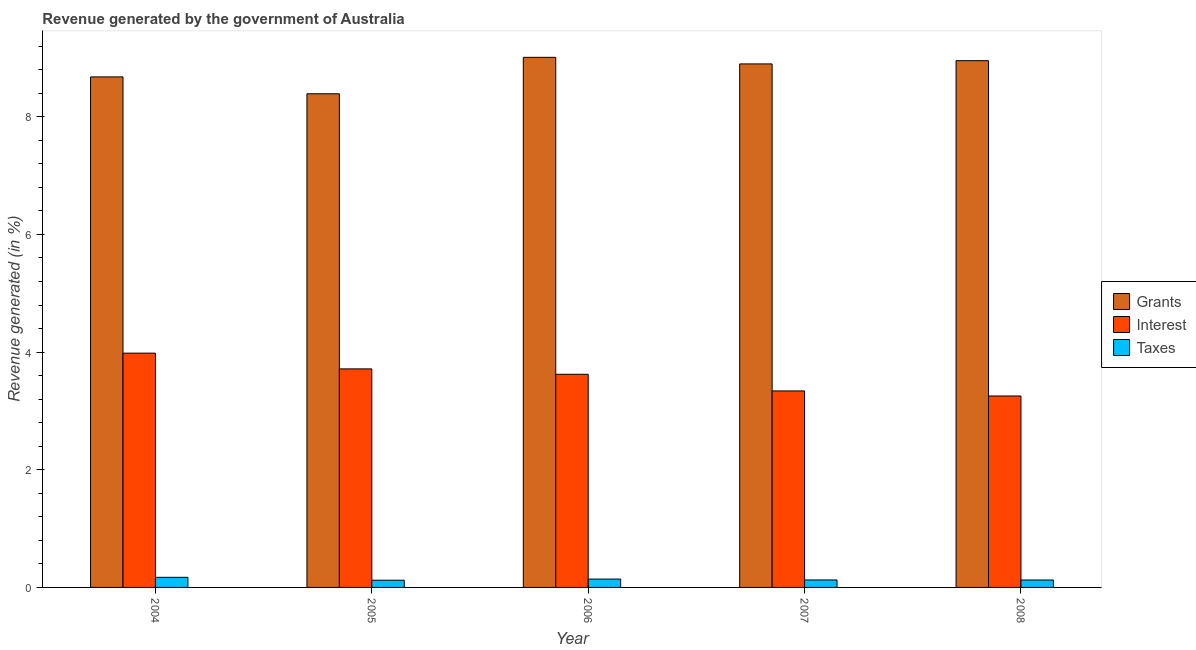How many groups of bars are there?
Ensure brevity in your answer.  5. Are the number of bars per tick equal to the number of legend labels?
Ensure brevity in your answer.  Yes. Are the number of bars on each tick of the X-axis equal?
Make the answer very short. Yes. How many bars are there on the 1st tick from the left?
Keep it short and to the point. 3. What is the percentage of revenue generated by grants in 2006?
Your answer should be compact. 9.01. Across all years, what is the maximum percentage of revenue generated by grants?
Make the answer very short. 9.01. Across all years, what is the minimum percentage of revenue generated by taxes?
Make the answer very short. 0.12. In which year was the percentage of revenue generated by taxes maximum?
Ensure brevity in your answer.  2004. In which year was the percentage of revenue generated by interest minimum?
Offer a very short reply. 2008. What is the total percentage of revenue generated by grants in the graph?
Give a very brief answer. 43.93. What is the difference between the percentage of revenue generated by grants in 2007 and that in 2008?
Ensure brevity in your answer.  -0.06. What is the difference between the percentage of revenue generated by grants in 2007 and the percentage of revenue generated by taxes in 2004?
Your answer should be compact. 0.22. What is the average percentage of revenue generated by taxes per year?
Provide a succinct answer. 0.14. In the year 2008, what is the difference between the percentage of revenue generated by grants and percentage of revenue generated by taxes?
Offer a terse response. 0. What is the ratio of the percentage of revenue generated by grants in 2004 to that in 2008?
Provide a short and direct response. 0.97. Is the percentage of revenue generated by taxes in 2004 less than that in 2008?
Give a very brief answer. No. What is the difference between the highest and the second highest percentage of revenue generated by taxes?
Offer a very short reply. 0.03. What is the difference between the highest and the lowest percentage of revenue generated by taxes?
Your answer should be very brief. 0.05. Is the sum of the percentage of revenue generated by grants in 2005 and 2008 greater than the maximum percentage of revenue generated by taxes across all years?
Provide a short and direct response. Yes. What does the 1st bar from the left in 2004 represents?
Give a very brief answer. Grants. What does the 1st bar from the right in 2004 represents?
Your response must be concise. Taxes. Is it the case that in every year, the sum of the percentage of revenue generated by grants and percentage of revenue generated by interest is greater than the percentage of revenue generated by taxes?
Provide a short and direct response. Yes. How many bars are there?
Offer a very short reply. 15. Are all the bars in the graph horizontal?
Offer a terse response. No. What is the difference between two consecutive major ticks on the Y-axis?
Make the answer very short. 2. Does the graph contain grids?
Ensure brevity in your answer.  No. How are the legend labels stacked?
Your response must be concise. Vertical. What is the title of the graph?
Keep it short and to the point. Revenue generated by the government of Australia. Does "Injury" appear as one of the legend labels in the graph?
Keep it short and to the point. No. What is the label or title of the Y-axis?
Your answer should be compact. Revenue generated (in %). What is the Revenue generated (in %) in Grants in 2004?
Keep it short and to the point. 8.68. What is the Revenue generated (in %) of Interest in 2004?
Your answer should be very brief. 3.98. What is the Revenue generated (in %) of Taxes in 2004?
Provide a short and direct response. 0.17. What is the Revenue generated (in %) of Grants in 2005?
Make the answer very short. 8.39. What is the Revenue generated (in %) in Interest in 2005?
Provide a short and direct response. 3.71. What is the Revenue generated (in %) of Taxes in 2005?
Offer a terse response. 0.12. What is the Revenue generated (in %) in Grants in 2006?
Keep it short and to the point. 9.01. What is the Revenue generated (in %) in Interest in 2006?
Your answer should be compact. 3.62. What is the Revenue generated (in %) of Taxes in 2006?
Give a very brief answer. 0.14. What is the Revenue generated (in %) in Grants in 2007?
Make the answer very short. 8.9. What is the Revenue generated (in %) in Interest in 2007?
Provide a succinct answer. 3.34. What is the Revenue generated (in %) of Taxes in 2007?
Your answer should be very brief. 0.13. What is the Revenue generated (in %) of Grants in 2008?
Make the answer very short. 8.95. What is the Revenue generated (in %) of Interest in 2008?
Make the answer very short. 3.25. What is the Revenue generated (in %) of Taxes in 2008?
Make the answer very short. 0.13. Across all years, what is the maximum Revenue generated (in %) in Grants?
Keep it short and to the point. 9.01. Across all years, what is the maximum Revenue generated (in %) of Interest?
Your answer should be compact. 3.98. Across all years, what is the maximum Revenue generated (in %) of Taxes?
Ensure brevity in your answer.  0.17. Across all years, what is the minimum Revenue generated (in %) in Grants?
Ensure brevity in your answer.  8.39. Across all years, what is the minimum Revenue generated (in %) in Interest?
Provide a short and direct response. 3.25. Across all years, what is the minimum Revenue generated (in %) in Taxes?
Keep it short and to the point. 0.12. What is the total Revenue generated (in %) of Grants in the graph?
Ensure brevity in your answer.  43.93. What is the total Revenue generated (in %) in Interest in the graph?
Offer a terse response. 17.91. What is the total Revenue generated (in %) in Taxes in the graph?
Ensure brevity in your answer.  0.69. What is the difference between the Revenue generated (in %) in Grants in 2004 and that in 2005?
Your answer should be very brief. 0.29. What is the difference between the Revenue generated (in %) in Interest in 2004 and that in 2005?
Provide a succinct answer. 0.27. What is the difference between the Revenue generated (in %) in Taxes in 2004 and that in 2005?
Your answer should be very brief. 0.05. What is the difference between the Revenue generated (in %) in Grants in 2004 and that in 2006?
Offer a very short reply. -0.33. What is the difference between the Revenue generated (in %) of Interest in 2004 and that in 2006?
Ensure brevity in your answer.  0.36. What is the difference between the Revenue generated (in %) of Taxes in 2004 and that in 2006?
Make the answer very short. 0.03. What is the difference between the Revenue generated (in %) of Grants in 2004 and that in 2007?
Offer a very short reply. -0.22. What is the difference between the Revenue generated (in %) of Interest in 2004 and that in 2007?
Ensure brevity in your answer.  0.64. What is the difference between the Revenue generated (in %) in Taxes in 2004 and that in 2007?
Offer a terse response. 0.04. What is the difference between the Revenue generated (in %) in Grants in 2004 and that in 2008?
Offer a very short reply. -0.28. What is the difference between the Revenue generated (in %) in Interest in 2004 and that in 2008?
Your answer should be compact. 0.73. What is the difference between the Revenue generated (in %) of Taxes in 2004 and that in 2008?
Make the answer very short. 0.05. What is the difference between the Revenue generated (in %) of Grants in 2005 and that in 2006?
Provide a short and direct response. -0.62. What is the difference between the Revenue generated (in %) in Interest in 2005 and that in 2006?
Your response must be concise. 0.09. What is the difference between the Revenue generated (in %) in Taxes in 2005 and that in 2006?
Provide a short and direct response. -0.02. What is the difference between the Revenue generated (in %) in Grants in 2005 and that in 2007?
Provide a succinct answer. -0.51. What is the difference between the Revenue generated (in %) of Interest in 2005 and that in 2007?
Provide a succinct answer. 0.37. What is the difference between the Revenue generated (in %) of Taxes in 2005 and that in 2007?
Give a very brief answer. -0. What is the difference between the Revenue generated (in %) of Grants in 2005 and that in 2008?
Provide a short and direct response. -0.56. What is the difference between the Revenue generated (in %) of Interest in 2005 and that in 2008?
Your answer should be compact. 0.46. What is the difference between the Revenue generated (in %) of Taxes in 2005 and that in 2008?
Ensure brevity in your answer.  -0. What is the difference between the Revenue generated (in %) in Grants in 2006 and that in 2007?
Give a very brief answer. 0.11. What is the difference between the Revenue generated (in %) of Interest in 2006 and that in 2007?
Your response must be concise. 0.28. What is the difference between the Revenue generated (in %) of Taxes in 2006 and that in 2007?
Make the answer very short. 0.02. What is the difference between the Revenue generated (in %) in Grants in 2006 and that in 2008?
Offer a terse response. 0.06. What is the difference between the Revenue generated (in %) in Interest in 2006 and that in 2008?
Your response must be concise. 0.37. What is the difference between the Revenue generated (in %) in Taxes in 2006 and that in 2008?
Offer a terse response. 0.02. What is the difference between the Revenue generated (in %) of Grants in 2007 and that in 2008?
Your response must be concise. -0.06. What is the difference between the Revenue generated (in %) in Interest in 2007 and that in 2008?
Your answer should be very brief. 0.09. What is the difference between the Revenue generated (in %) of Taxes in 2007 and that in 2008?
Ensure brevity in your answer.  0. What is the difference between the Revenue generated (in %) of Grants in 2004 and the Revenue generated (in %) of Interest in 2005?
Offer a terse response. 4.96. What is the difference between the Revenue generated (in %) in Grants in 2004 and the Revenue generated (in %) in Taxes in 2005?
Your answer should be very brief. 8.56. What is the difference between the Revenue generated (in %) of Interest in 2004 and the Revenue generated (in %) of Taxes in 2005?
Your response must be concise. 3.86. What is the difference between the Revenue generated (in %) of Grants in 2004 and the Revenue generated (in %) of Interest in 2006?
Keep it short and to the point. 5.05. What is the difference between the Revenue generated (in %) in Grants in 2004 and the Revenue generated (in %) in Taxes in 2006?
Provide a short and direct response. 8.54. What is the difference between the Revenue generated (in %) of Interest in 2004 and the Revenue generated (in %) of Taxes in 2006?
Provide a succinct answer. 3.84. What is the difference between the Revenue generated (in %) of Grants in 2004 and the Revenue generated (in %) of Interest in 2007?
Provide a succinct answer. 5.34. What is the difference between the Revenue generated (in %) of Grants in 2004 and the Revenue generated (in %) of Taxes in 2007?
Provide a succinct answer. 8.55. What is the difference between the Revenue generated (in %) in Interest in 2004 and the Revenue generated (in %) in Taxes in 2007?
Keep it short and to the point. 3.86. What is the difference between the Revenue generated (in %) of Grants in 2004 and the Revenue generated (in %) of Interest in 2008?
Your answer should be compact. 5.42. What is the difference between the Revenue generated (in %) of Grants in 2004 and the Revenue generated (in %) of Taxes in 2008?
Make the answer very short. 8.55. What is the difference between the Revenue generated (in %) in Interest in 2004 and the Revenue generated (in %) in Taxes in 2008?
Keep it short and to the point. 3.86. What is the difference between the Revenue generated (in %) of Grants in 2005 and the Revenue generated (in %) of Interest in 2006?
Give a very brief answer. 4.77. What is the difference between the Revenue generated (in %) of Grants in 2005 and the Revenue generated (in %) of Taxes in 2006?
Provide a short and direct response. 8.25. What is the difference between the Revenue generated (in %) of Interest in 2005 and the Revenue generated (in %) of Taxes in 2006?
Make the answer very short. 3.57. What is the difference between the Revenue generated (in %) of Grants in 2005 and the Revenue generated (in %) of Interest in 2007?
Give a very brief answer. 5.05. What is the difference between the Revenue generated (in %) of Grants in 2005 and the Revenue generated (in %) of Taxes in 2007?
Provide a short and direct response. 8.26. What is the difference between the Revenue generated (in %) of Interest in 2005 and the Revenue generated (in %) of Taxes in 2007?
Make the answer very short. 3.59. What is the difference between the Revenue generated (in %) in Grants in 2005 and the Revenue generated (in %) in Interest in 2008?
Provide a succinct answer. 5.14. What is the difference between the Revenue generated (in %) in Grants in 2005 and the Revenue generated (in %) in Taxes in 2008?
Your response must be concise. 8.26. What is the difference between the Revenue generated (in %) of Interest in 2005 and the Revenue generated (in %) of Taxes in 2008?
Make the answer very short. 3.59. What is the difference between the Revenue generated (in %) in Grants in 2006 and the Revenue generated (in %) in Interest in 2007?
Provide a succinct answer. 5.67. What is the difference between the Revenue generated (in %) of Grants in 2006 and the Revenue generated (in %) of Taxes in 2007?
Give a very brief answer. 8.88. What is the difference between the Revenue generated (in %) in Interest in 2006 and the Revenue generated (in %) in Taxes in 2007?
Your answer should be compact. 3.5. What is the difference between the Revenue generated (in %) of Grants in 2006 and the Revenue generated (in %) of Interest in 2008?
Provide a short and direct response. 5.76. What is the difference between the Revenue generated (in %) of Grants in 2006 and the Revenue generated (in %) of Taxes in 2008?
Provide a succinct answer. 8.88. What is the difference between the Revenue generated (in %) of Interest in 2006 and the Revenue generated (in %) of Taxes in 2008?
Provide a short and direct response. 3.5. What is the difference between the Revenue generated (in %) of Grants in 2007 and the Revenue generated (in %) of Interest in 2008?
Offer a very short reply. 5.64. What is the difference between the Revenue generated (in %) in Grants in 2007 and the Revenue generated (in %) in Taxes in 2008?
Your response must be concise. 8.77. What is the difference between the Revenue generated (in %) of Interest in 2007 and the Revenue generated (in %) of Taxes in 2008?
Make the answer very short. 3.21. What is the average Revenue generated (in %) in Grants per year?
Offer a very short reply. 8.79. What is the average Revenue generated (in %) of Interest per year?
Keep it short and to the point. 3.58. What is the average Revenue generated (in %) in Taxes per year?
Offer a terse response. 0.14. In the year 2004, what is the difference between the Revenue generated (in %) in Grants and Revenue generated (in %) in Interest?
Provide a succinct answer. 4.7. In the year 2004, what is the difference between the Revenue generated (in %) of Grants and Revenue generated (in %) of Taxes?
Your answer should be very brief. 8.51. In the year 2004, what is the difference between the Revenue generated (in %) in Interest and Revenue generated (in %) in Taxes?
Offer a very short reply. 3.81. In the year 2005, what is the difference between the Revenue generated (in %) of Grants and Revenue generated (in %) of Interest?
Your answer should be compact. 4.68. In the year 2005, what is the difference between the Revenue generated (in %) in Grants and Revenue generated (in %) in Taxes?
Ensure brevity in your answer.  8.27. In the year 2005, what is the difference between the Revenue generated (in %) of Interest and Revenue generated (in %) of Taxes?
Provide a succinct answer. 3.59. In the year 2006, what is the difference between the Revenue generated (in %) in Grants and Revenue generated (in %) in Interest?
Make the answer very short. 5.39. In the year 2006, what is the difference between the Revenue generated (in %) of Grants and Revenue generated (in %) of Taxes?
Give a very brief answer. 8.87. In the year 2006, what is the difference between the Revenue generated (in %) of Interest and Revenue generated (in %) of Taxes?
Provide a succinct answer. 3.48. In the year 2007, what is the difference between the Revenue generated (in %) in Grants and Revenue generated (in %) in Interest?
Make the answer very short. 5.56. In the year 2007, what is the difference between the Revenue generated (in %) of Grants and Revenue generated (in %) of Taxes?
Provide a short and direct response. 8.77. In the year 2007, what is the difference between the Revenue generated (in %) in Interest and Revenue generated (in %) in Taxes?
Provide a short and direct response. 3.21. In the year 2008, what is the difference between the Revenue generated (in %) of Grants and Revenue generated (in %) of Interest?
Offer a terse response. 5.7. In the year 2008, what is the difference between the Revenue generated (in %) in Grants and Revenue generated (in %) in Taxes?
Keep it short and to the point. 8.83. In the year 2008, what is the difference between the Revenue generated (in %) in Interest and Revenue generated (in %) in Taxes?
Keep it short and to the point. 3.13. What is the ratio of the Revenue generated (in %) of Grants in 2004 to that in 2005?
Ensure brevity in your answer.  1.03. What is the ratio of the Revenue generated (in %) in Interest in 2004 to that in 2005?
Give a very brief answer. 1.07. What is the ratio of the Revenue generated (in %) of Taxes in 2004 to that in 2005?
Your response must be concise. 1.4. What is the ratio of the Revenue generated (in %) in Grants in 2004 to that in 2006?
Keep it short and to the point. 0.96. What is the ratio of the Revenue generated (in %) in Interest in 2004 to that in 2006?
Provide a short and direct response. 1.1. What is the ratio of the Revenue generated (in %) in Taxes in 2004 to that in 2006?
Your answer should be compact. 1.21. What is the ratio of the Revenue generated (in %) in Grants in 2004 to that in 2007?
Ensure brevity in your answer.  0.98. What is the ratio of the Revenue generated (in %) in Interest in 2004 to that in 2007?
Provide a succinct answer. 1.19. What is the ratio of the Revenue generated (in %) of Taxes in 2004 to that in 2007?
Keep it short and to the point. 1.35. What is the ratio of the Revenue generated (in %) in Grants in 2004 to that in 2008?
Provide a succinct answer. 0.97. What is the ratio of the Revenue generated (in %) of Interest in 2004 to that in 2008?
Keep it short and to the point. 1.22. What is the ratio of the Revenue generated (in %) of Taxes in 2004 to that in 2008?
Ensure brevity in your answer.  1.36. What is the ratio of the Revenue generated (in %) of Grants in 2005 to that in 2006?
Your answer should be compact. 0.93. What is the ratio of the Revenue generated (in %) of Interest in 2005 to that in 2006?
Give a very brief answer. 1.03. What is the ratio of the Revenue generated (in %) in Taxes in 2005 to that in 2006?
Keep it short and to the point. 0.86. What is the ratio of the Revenue generated (in %) in Grants in 2005 to that in 2007?
Ensure brevity in your answer.  0.94. What is the ratio of the Revenue generated (in %) in Interest in 2005 to that in 2007?
Keep it short and to the point. 1.11. What is the ratio of the Revenue generated (in %) in Taxes in 2005 to that in 2007?
Provide a succinct answer. 0.96. What is the ratio of the Revenue generated (in %) in Grants in 2005 to that in 2008?
Make the answer very short. 0.94. What is the ratio of the Revenue generated (in %) in Interest in 2005 to that in 2008?
Your answer should be very brief. 1.14. What is the ratio of the Revenue generated (in %) in Taxes in 2005 to that in 2008?
Give a very brief answer. 0.97. What is the ratio of the Revenue generated (in %) in Grants in 2006 to that in 2007?
Offer a terse response. 1.01. What is the ratio of the Revenue generated (in %) of Interest in 2006 to that in 2007?
Your response must be concise. 1.08. What is the ratio of the Revenue generated (in %) in Taxes in 2006 to that in 2007?
Offer a terse response. 1.12. What is the ratio of the Revenue generated (in %) in Grants in 2006 to that in 2008?
Make the answer very short. 1.01. What is the ratio of the Revenue generated (in %) of Interest in 2006 to that in 2008?
Your answer should be compact. 1.11. What is the ratio of the Revenue generated (in %) in Taxes in 2006 to that in 2008?
Provide a short and direct response. 1.13. What is the ratio of the Revenue generated (in %) of Grants in 2007 to that in 2008?
Offer a very short reply. 0.99. What is the ratio of the Revenue generated (in %) in Interest in 2007 to that in 2008?
Keep it short and to the point. 1.03. What is the ratio of the Revenue generated (in %) in Taxes in 2007 to that in 2008?
Offer a very short reply. 1.01. What is the difference between the highest and the second highest Revenue generated (in %) of Grants?
Provide a short and direct response. 0.06. What is the difference between the highest and the second highest Revenue generated (in %) of Interest?
Offer a terse response. 0.27. What is the difference between the highest and the second highest Revenue generated (in %) of Taxes?
Offer a terse response. 0.03. What is the difference between the highest and the lowest Revenue generated (in %) in Grants?
Offer a terse response. 0.62. What is the difference between the highest and the lowest Revenue generated (in %) of Interest?
Your answer should be very brief. 0.73. What is the difference between the highest and the lowest Revenue generated (in %) of Taxes?
Provide a short and direct response. 0.05. 